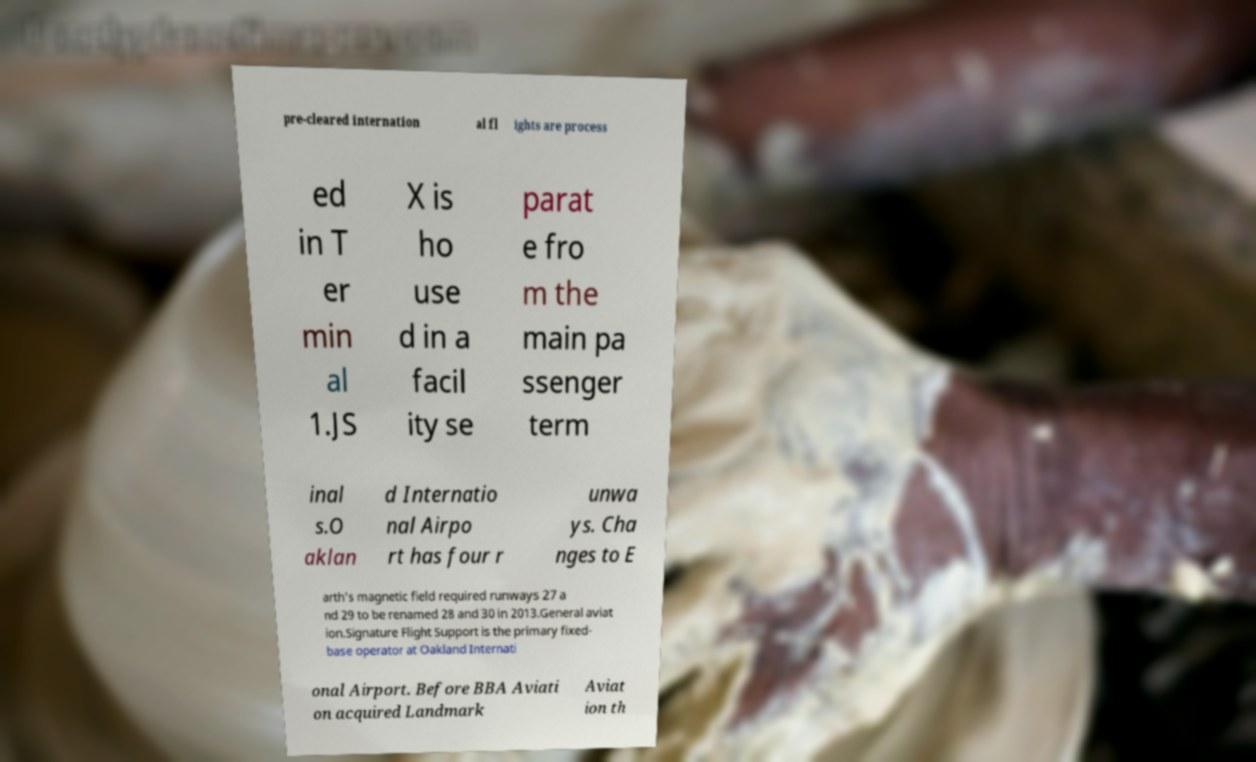Please read and relay the text visible in this image. What does it say? pre-cleared internation al fl ights are process ed in T er min al 1.JS X is ho use d in a facil ity se parat e fro m the main pa ssenger term inal s.O aklan d Internatio nal Airpo rt has four r unwa ys. Cha nges to E arth's magnetic field required runways 27 a nd 29 to be renamed 28 and 30 in 2013.General aviat ion.Signature Flight Support is the primary fixed- base operator at Oakland Internati onal Airport. Before BBA Aviati on acquired Landmark Aviat ion th 